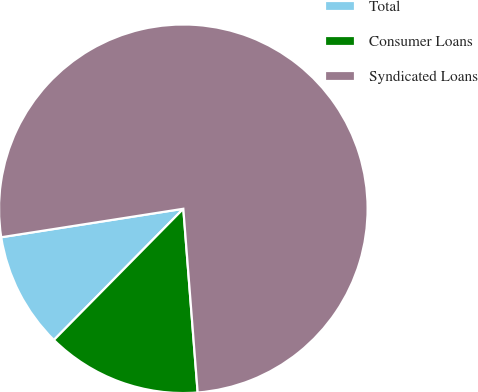<chart> <loc_0><loc_0><loc_500><loc_500><pie_chart><fcel>Total<fcel>Consumer Loans<fcel>Syndicated Loans<nl><fcel>10.14%<fcel>13.63%<fcel>76.23%<nl></chart> 